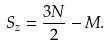<formula> <loc_0><loc_0><loc_500><loc_500>S _ { z } = \frac { 3 N } { 2 } - M .</formula> 